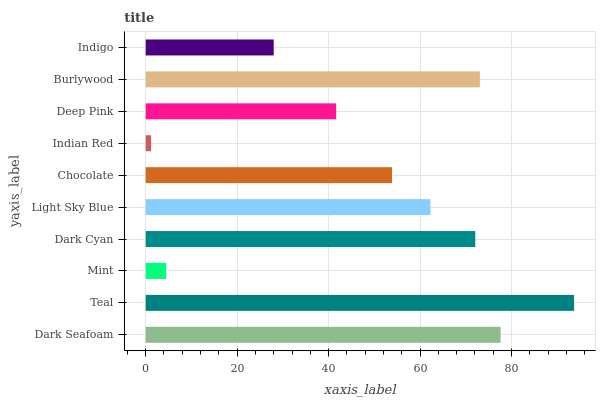Is Indian Red the minimum?
Answer yes or no. Yes. Is Teal the maximum?
Answer yes or no. Yes. Is Mint the minimum?
Answer yes or no. No. Is Mint the maximum?
Answer yes or no. No. Is Teal greater than Mint?
Answer yes or no. Yes. Is Mint less than Teal?
Answer yes or no. Yes. Is Mint greater than Teal?
Answer yes or no. No. Is Teal less than Mint?
Answer yes or no. No. Is Light Sky Blue the high median?
Answer yes or no. Yes. Is Chocolate the low median?
Answer yes or no. Yes. Is Burlywood the high median?
Answer yes or no. No. Is Deep Pink the low median?
Answer yes or no. No. 